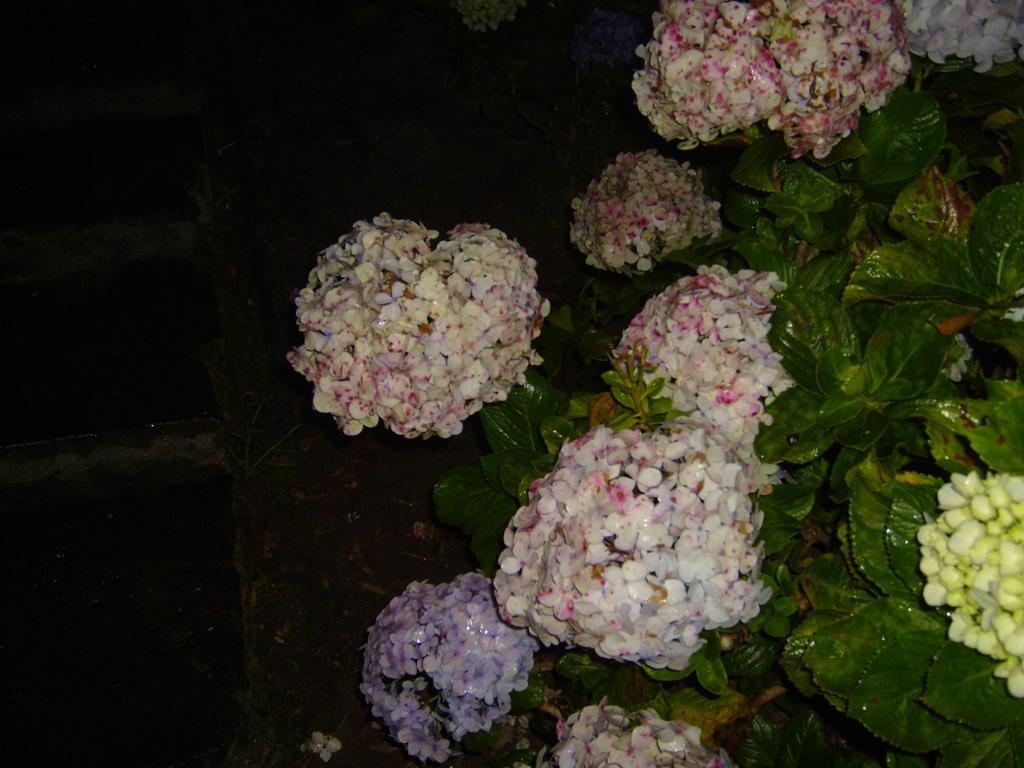Can you describe this image briefly? In the picture there are many plants present, there are flowers present. 